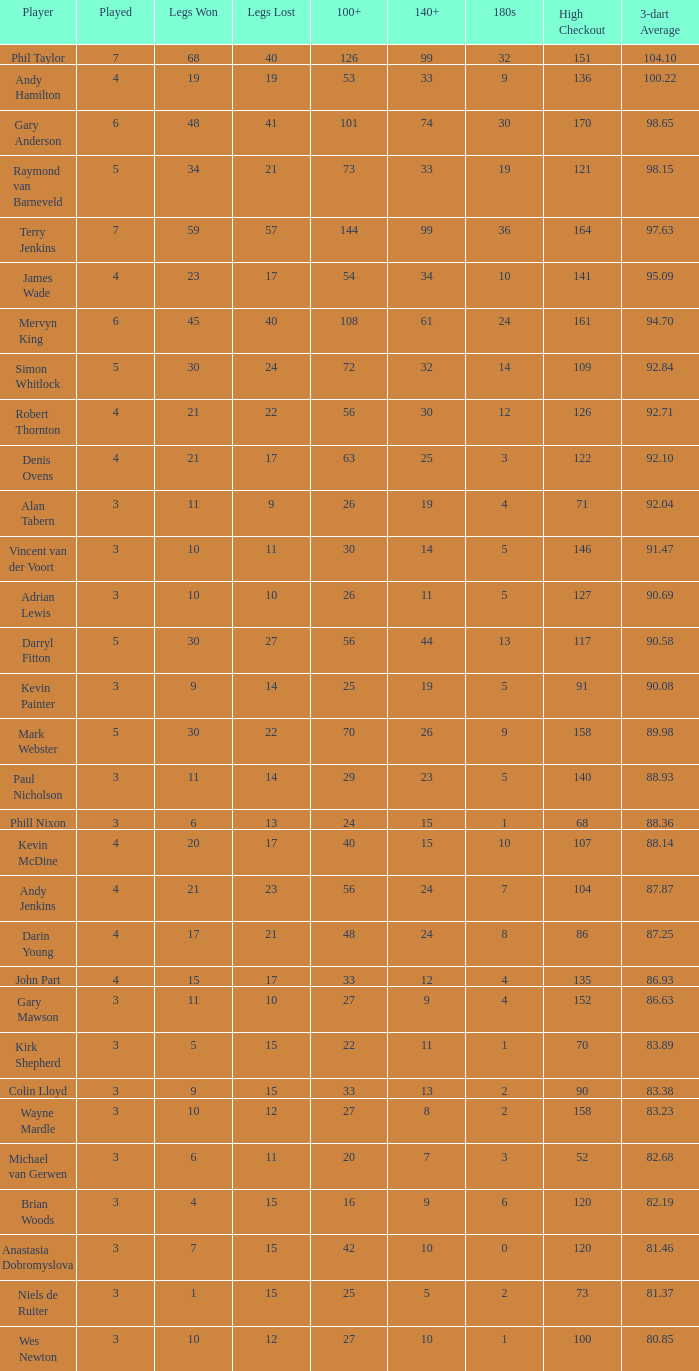Who is the player with 41 legs lost? Gary Anderson. 